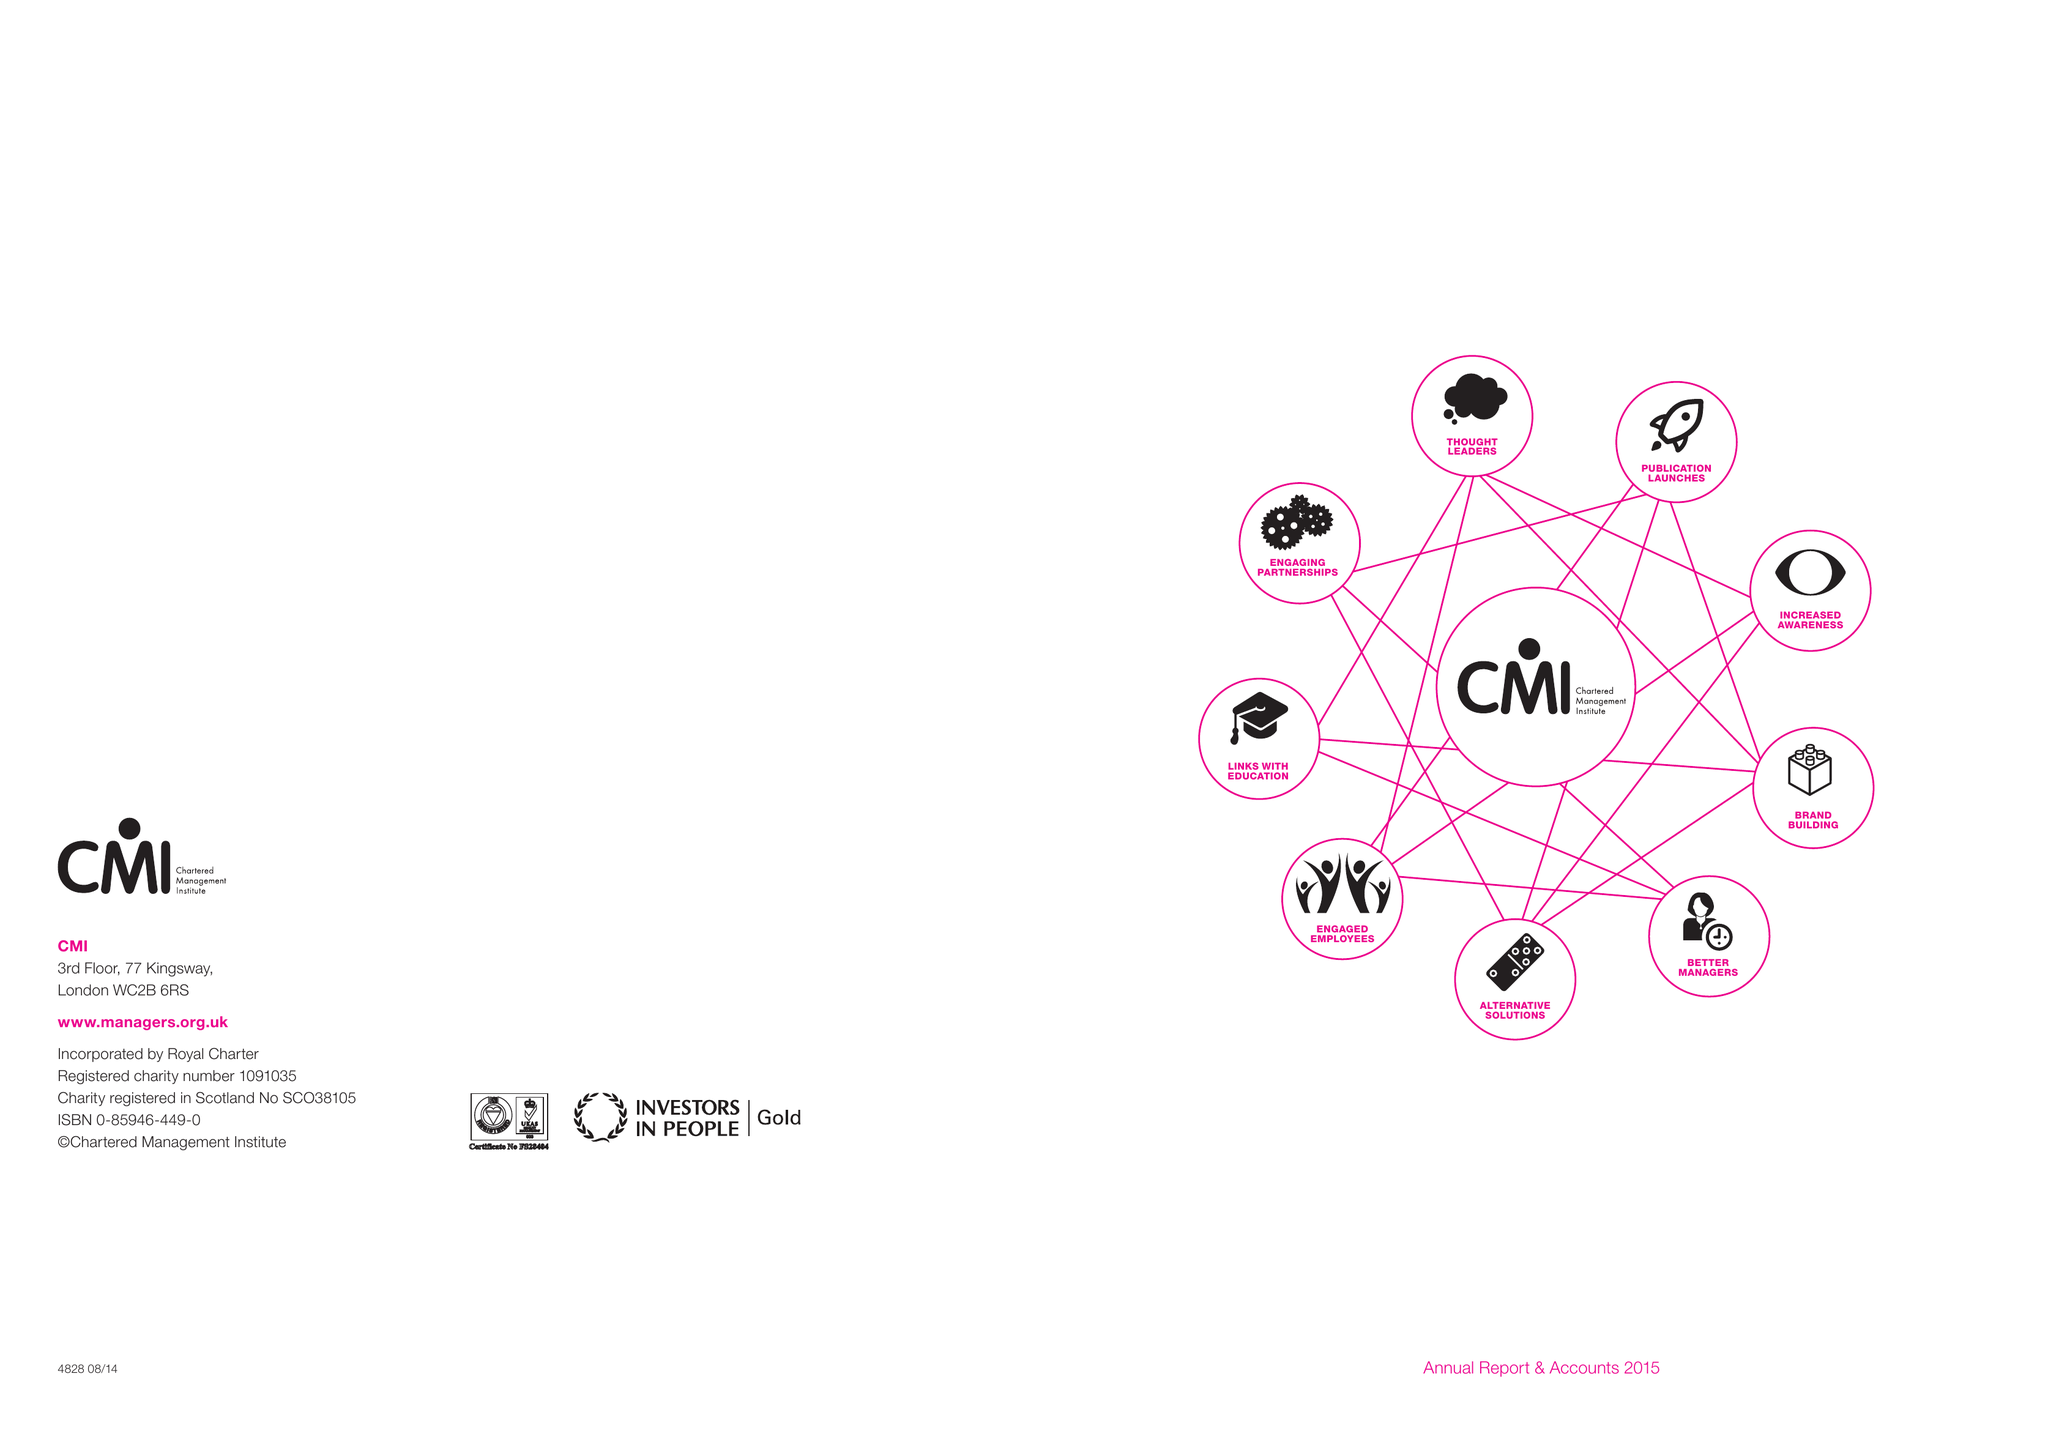What is the value for the charity_number?
Answer the question using a single word or phrase. 1091035 